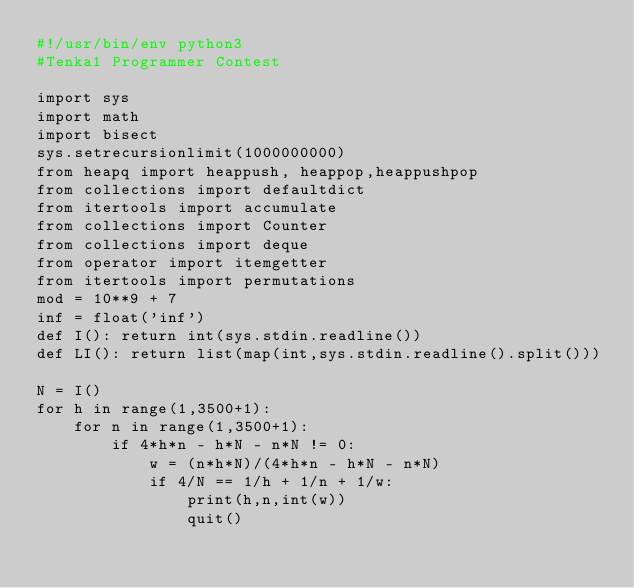<code> <loc_0><loc_0><loc_500><loc_500><_Python_>#!/usr/bin/env python3
#Tenka1 Programmer Contest

import sys
import math
import bisect
sys.setrecursionlimit(1000000000)
from heapq import heappush, heappop,heappushpop
from collections import defaultdict
from itertools import accumulate
from collections import Counter
from collections import deque
from operator import itemgetter
from itertools import permutations
mod = 10**9 + 7
inf = float('inf')
def I(): return int(sys.stdin.readline())
def LI(): return list(map(int,sys.stdin.readline().split()))

N = I()
for h in range(1,3500+1):
    for n in range(1,3500+1):
        if 4*h*n - h*N - n*N != 0:
            w = (n*h*N)/(4*h*n - h*N - n*N)
            if 4/N == 1/h + 1/n + 1/w:
                print(h,n,int(w))
                quit()
</code> 